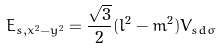Convert formula to latex. <formula><loc_0><loc_0><loc_500><loc_500>E _ { s , x ^ { 2 } - y ^ { 2 } } = { \frac { \sqrt { 3 } } { 2 } } ( l ^ { 2 } - m ^ { 2 } ) V _ { s d \sigma }</formula> 